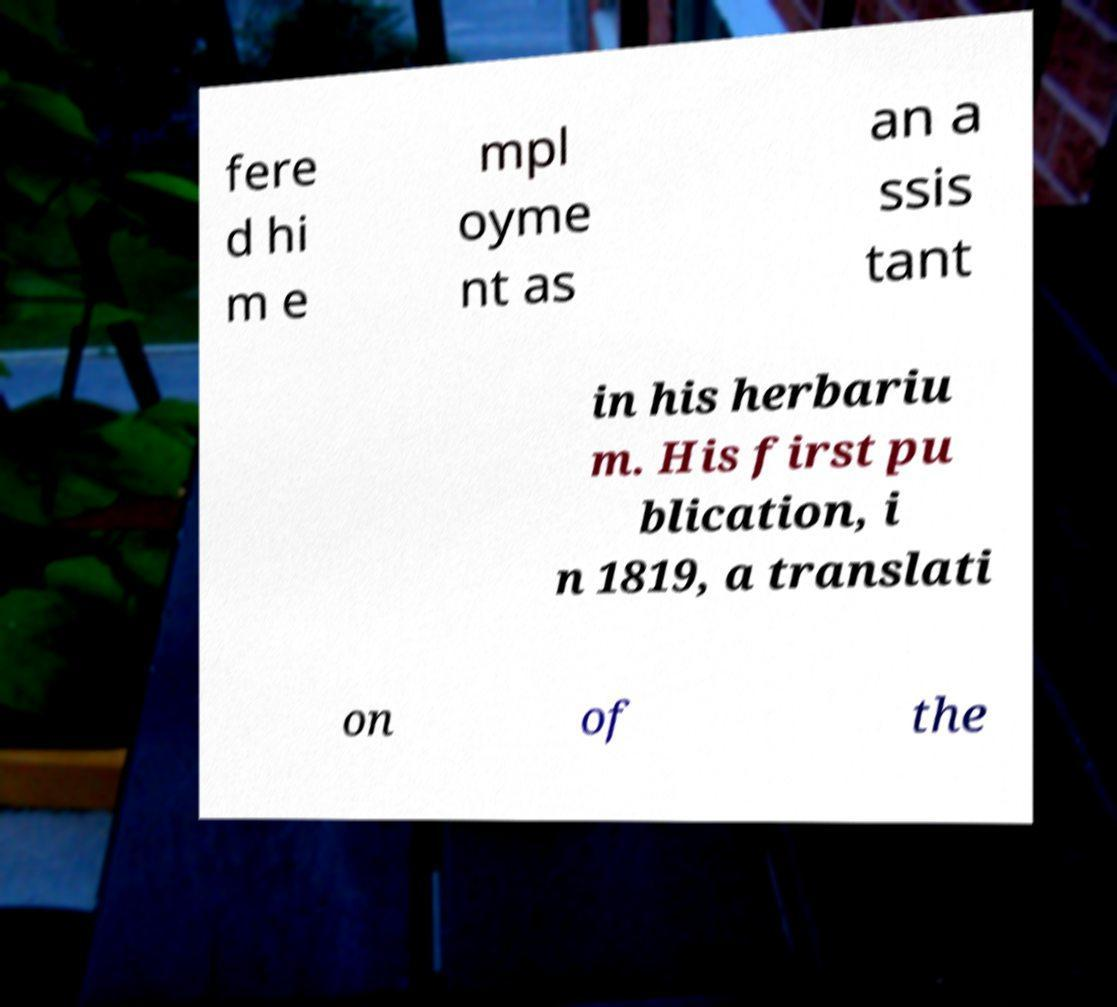Can you read and provide the text displayed in the image?This photo seems to have some interesting text. Can you extract and type it out for me? fere d hi m e mpl oyme nt as an a ssis tant in his herbariu m. His first pu blication, i n 1819, a translati on of the 